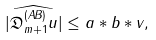<formula> <loc_0><loc_0><loc_500><loc_500>| \widehat { \mathfrak { D } _ { m + 1 } ^ { ( A B ) } u } | \leq a \ast b \ast v ,</formula> 